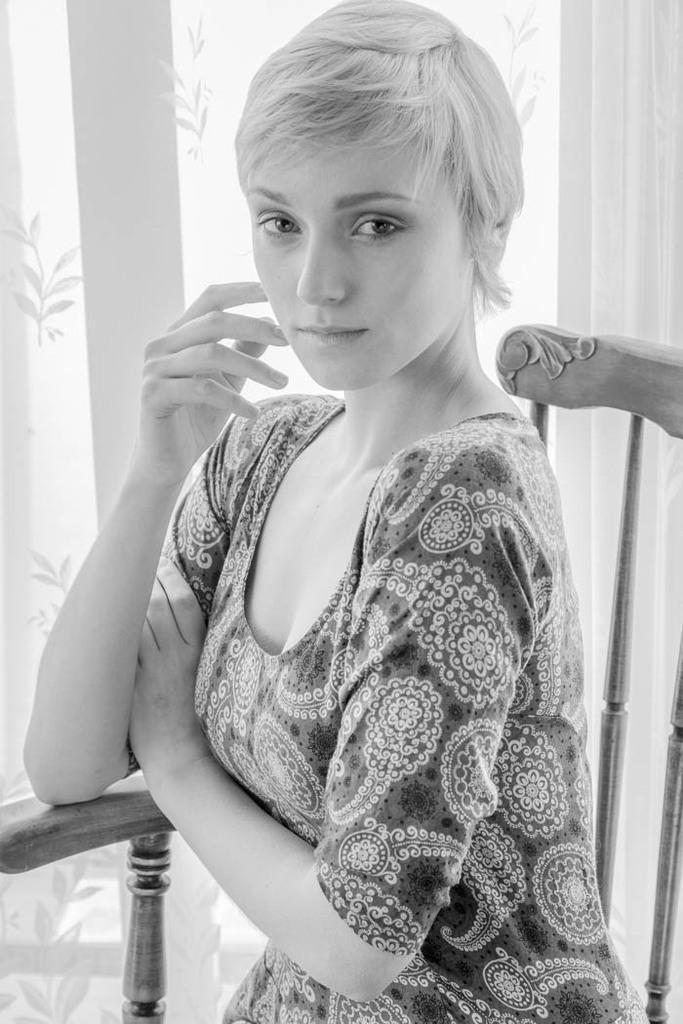Can you describe this image briefly? This is a black and white image. In this image we can see a woman sitting on a chair. On the backside we can see a curtain. 